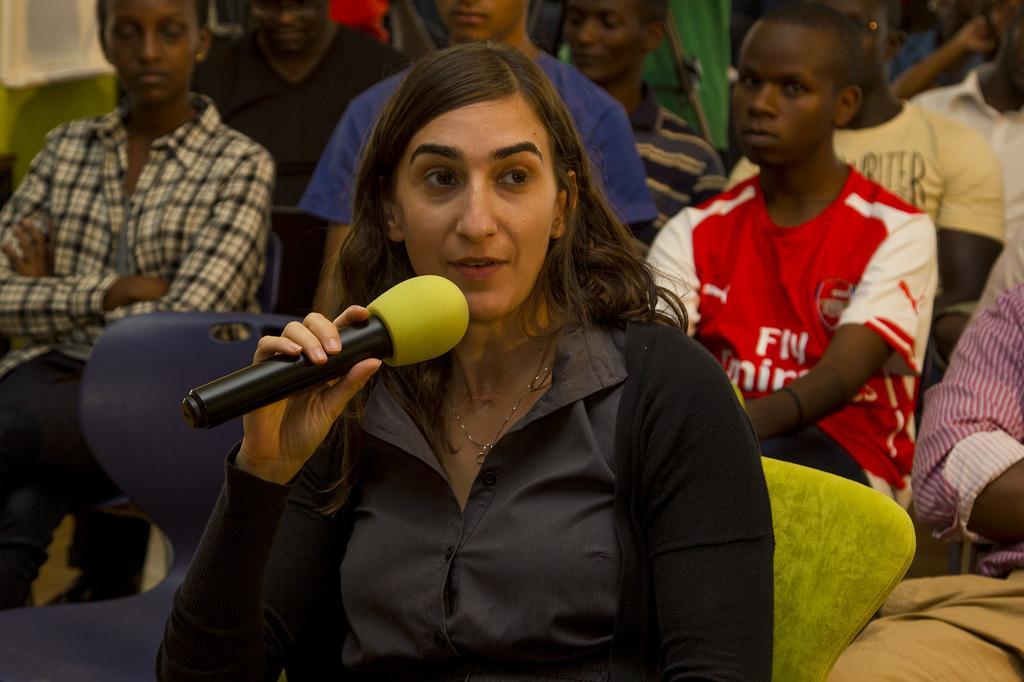In one or two sentences, can you explain what this image depicts? there is a woman speaking a microphone behind her so many people sitting on a chairs. 